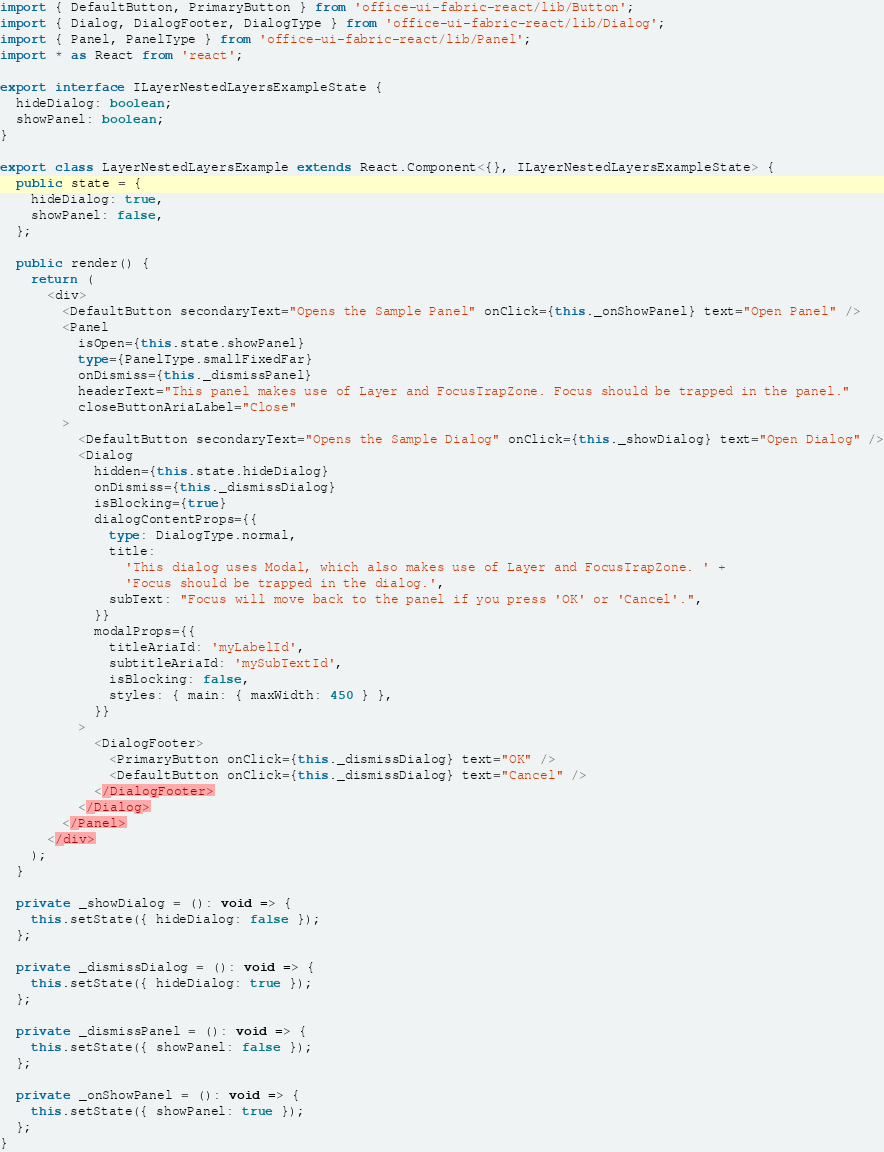Convert code to text. <code><loc_0><loc_0><loc_500><loc_500><_TypeScript_>import { DefaultButton, PrimaryButton } from 'office-ui-fabric-react/lib/Button';
import { Dialog, DialogFooter, DialogType } from 'office-ui-fabric-react/lib/Dialog';
import { Panel, PanelType } from 'office-ui-fabric-react/lib/Panel';
import * as React from 'react';

export interface ILayerNestedLayersExampleState {
  hideDialog: boolean;
  showPanel: boolean;
}

export class LayerNestedLayersExample extends React.Component<{}, ILayerNestedLayersExampleState> {
  public state = {
    hideDialog: true,
    showPanel: false,
  };

  public render() {
    return (
      <div>
        <DefaultButton secondaryText="Opens the Sample Panel" onClick={this._onShowPanel} text="Open Panel" />
        <Panel
          isOpen={this.state.showPanel}
          type={PanelType.smallFixedFar}
          onDismiss={this._dismissPanel}
          headerText="This panel makes use of Layer and FocusTrapZone. Focus should be trapped in the panel."
          closeButtonAriaLabel="Close"
        >
          <DefaultButton secondaryText="Opens the Sample Dialog" onClick={this._showDialog} text="Open Dialog" />
          <Dialog
            hidden={this.state.hideDialog}
            onDismiss={this._dismissDialog}
            isBlocking={true}
            dialogContentProps={{
              type: DialogType.normal,
              title:
                'This dialog uses Modal, which also makes use of Layer and FocusTrapZone. ' +
                'Focus should be trapped in the dialog.',
              subText: "Focus will move back to the panel if you press 'OK' or 'Cancel'.",
            }}
            modalProps={{
              titleAriaId: 'myLabelId',
              subtitleAriaId: 'mySubTextId',
              isBlocking: false,
              styles: { main: { maxWidth: 450 } },
            }}
          >
            <DialogFooter>
              <PrimaryButton onClick={this._dismissDialog} text="OK" />
              <DefaultButton onClick={this._dismissDialog} text="Cancel" />
            </DialogFooter>
          </Dialog>
        </Panel>
      </div>
    );
  }

  private _showDialog = (): void => {
    this.setState({ hideDialog: false });
  };

  private _dismissDialog = (): void => {
    this.setState({ hideDialog: true });
  };

  private _dismissPanel = (): void => {
    this.setState({ showPanel: false });
  };

  private _onShowPanel = (): void => {
    this.setState({ showPanel: true });
  };
}
</code> 